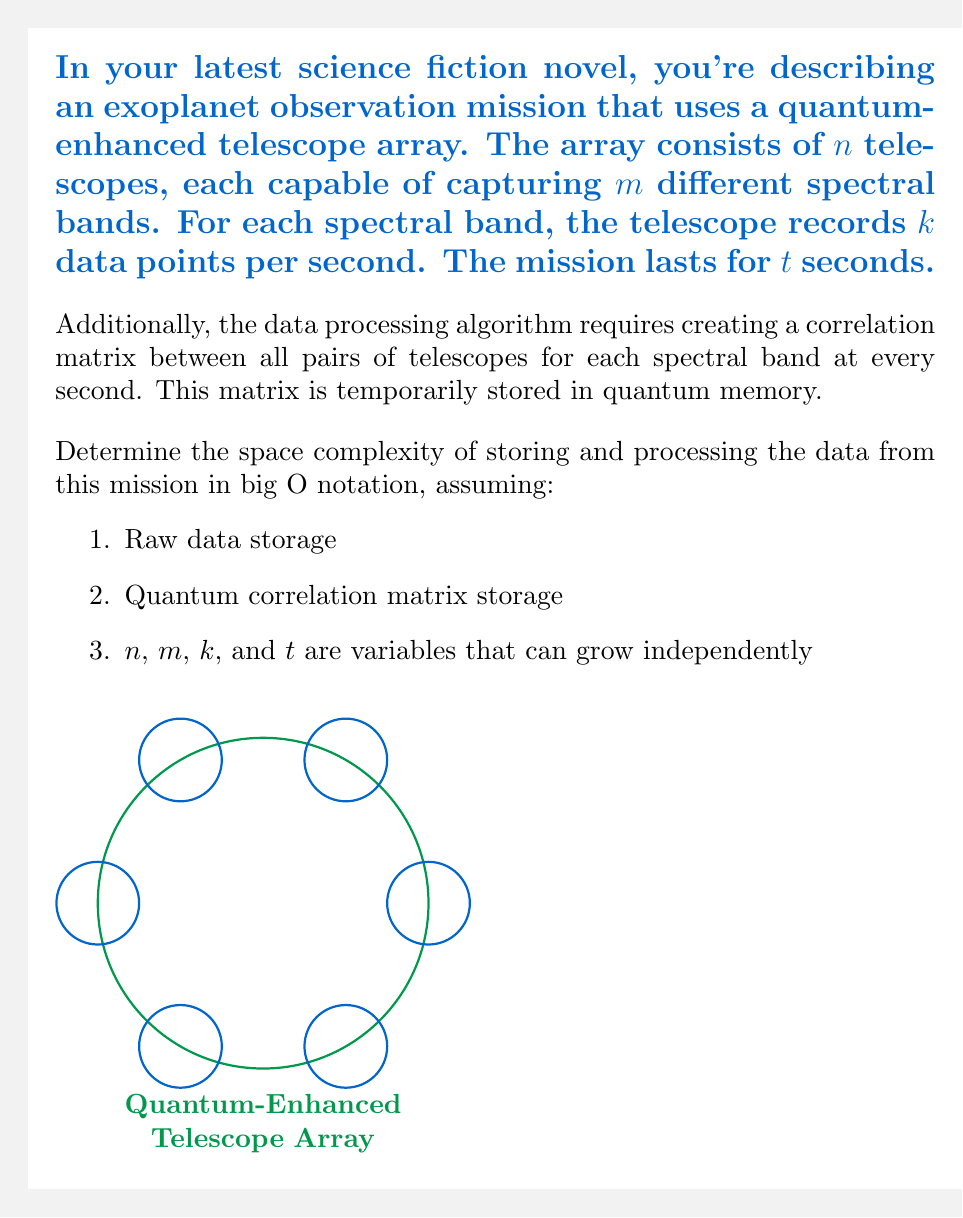Solve this math problem. Let's break this down step-by-step:

1. Raw data storage:
   - Each telescope captures $m$ spectral bands
   - Each band has $k$ data points per second
   - The mission lasts for $t$ seconds
   - There are $n$ telescopes
   
   So, the total raw data storage is:
   $$O(n \cdot m \cdot k \cdot t)$$

2. Quantum correlation matrix storage:
   - We need a correlation matrix for each spectral band at every second
   - The correlation matrix size is $n \times n$ (all pairs of telescopes)
   - There are $m$ spectral bands
   - This is done for each of the $t$ seconds
   
   So, the quantum correlation matrix storage is:
   $$O(n^2 \cdot m \cdot t)$$

3. Total space complexity:
   We need to sum up both storage requirements:
   $$O(n \cdot m \cdot k \cdot t + n^2 \cdot m \cdot t)$$

   This can be simplified to:
   $$O(m \cdot t \cdot (n \cdot k + n^2))$$

   Since $n$, $m$, $k$, and $t$ can grow independently, we cannot simplify this further.
Answer: $O(m \cdot t \cdot (n \cdot k + n^2))$ 